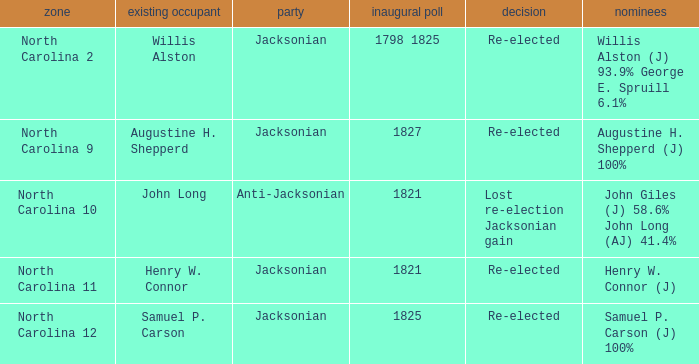Name the total number of party for willis alston (j) 93.9% george e. spruill 6.1% 1.0. 